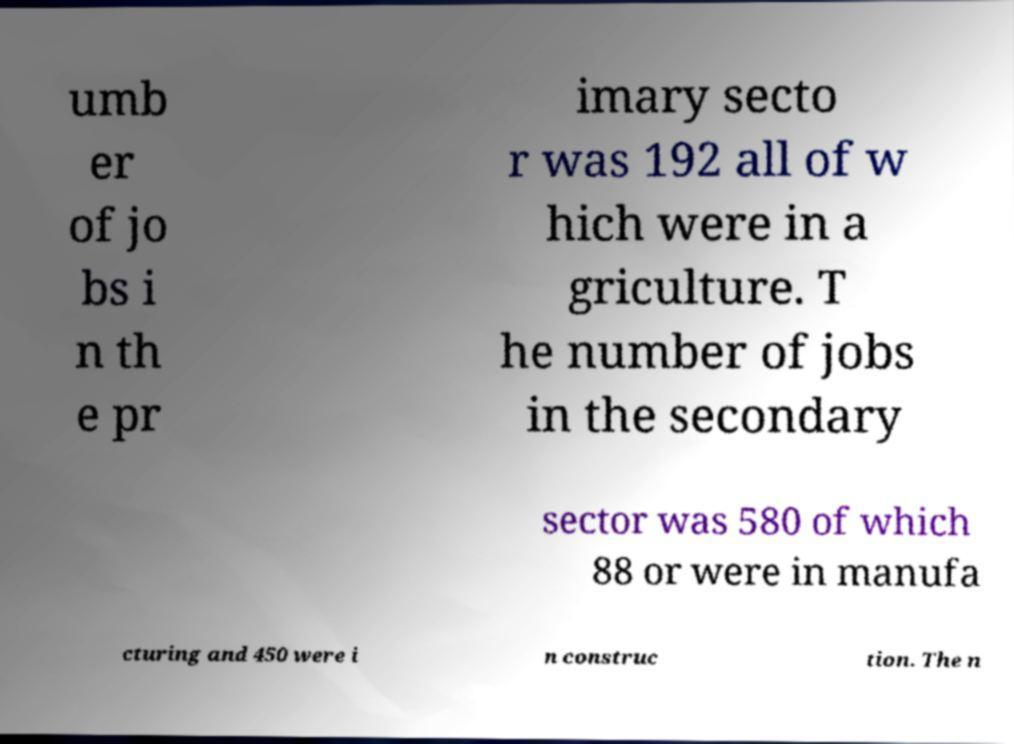Can you accurately transcribe the text from the provided image for me? umb er of jo bs i n th e pr imary secto r was 192 all of w hich were in a griculture. T he number of jobs in the secondary sector was 580 of which 88 or were in manufa cturing and 450 were i n construc tion. The n 